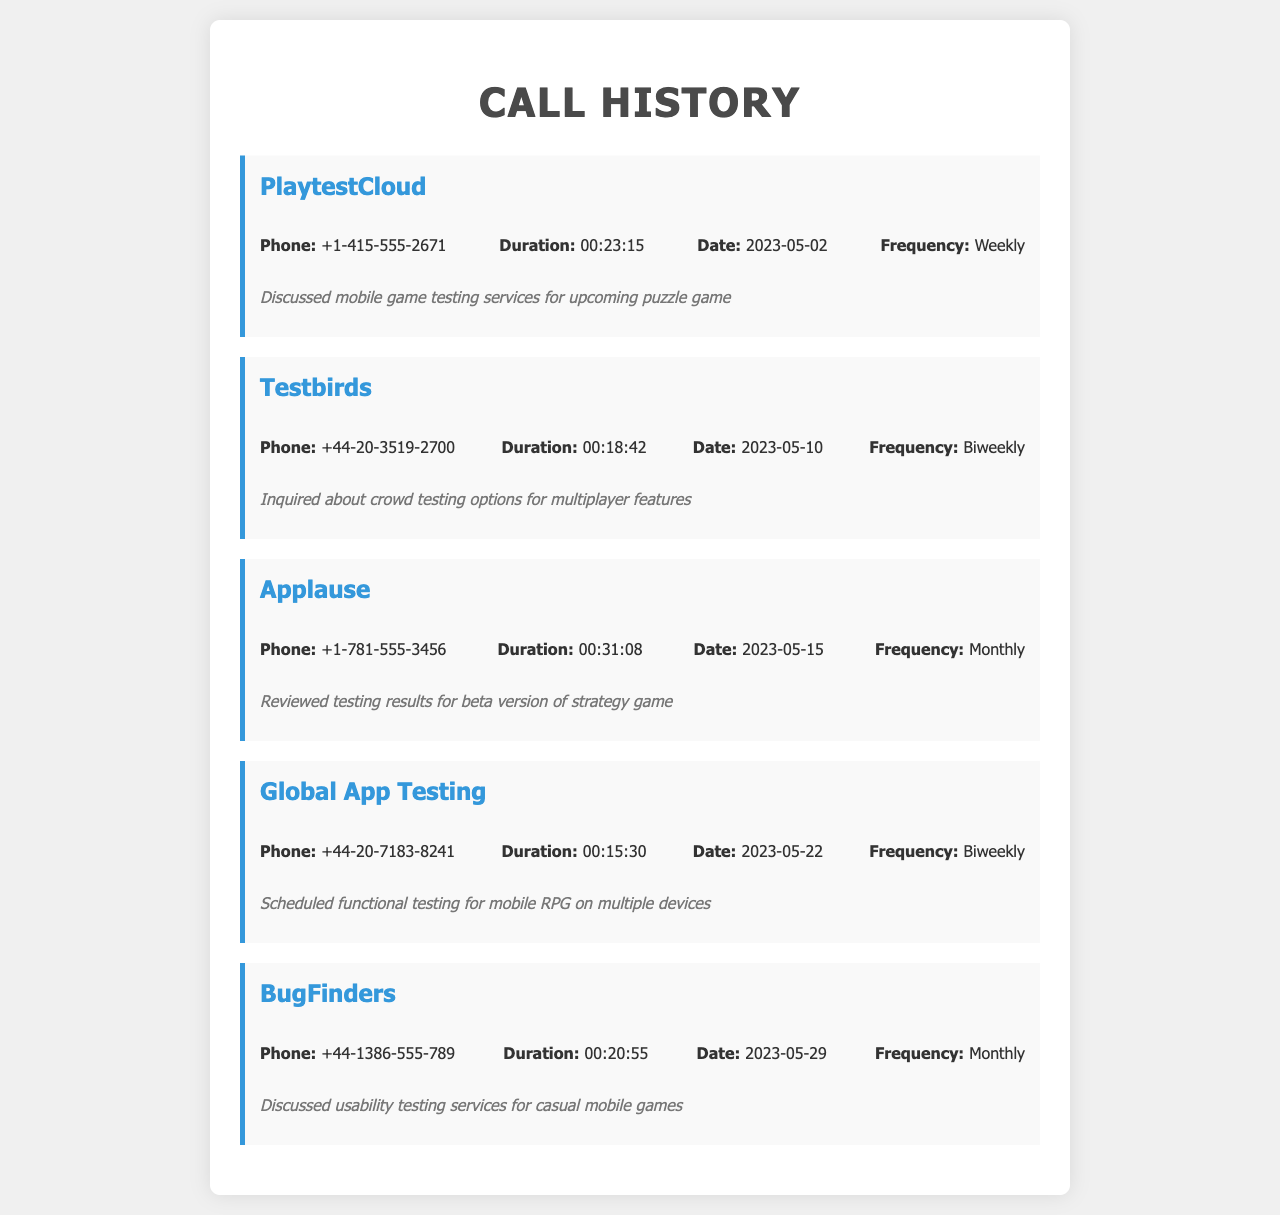What is the phone number for PlaytestCloud? The phone number is provided in the call record for PlaytestCloud, which lists +1-415-555-2671.
Answer: +1-415-555-2671 How long was the call with Testbirds? The duration of the call with Testbirds is listed as 00:18:42.
Answer: 00:18:42 On which date did the call with Applause occur? The date of the call with Applause is mentioned as 2023-05-15.
Answer: 2023-05-15 What type of testing was scheduled with Global App Testing? The notes specify that functional testing for a mobile RPG was scheduled.
Answer: Functional testing for mobile RPG How often do you communicate with BugFinders? The frequency of communication with BugFinders is listed as Monthly.
Answer: Monthly Which service discussed options for multiplayer features? The call record identifies Testbirds as the service discussing options for multiplayer features.
Answer: Testbirds What was a key subject in the call with PlaytestCloud? The notes indicate that the subject discussed was mobile game testing services for an upcoming puzzle game.
Answer: Mobile game testing services for upcoming puzzle game Which company had the longest call duration? The call record shows that Applause had the longest duration at 00:31:08.
Answer: 00:31:08 How many companies are listed in the call history? A count of the entries indicates that there are five companies listed in the call history.
Answer: Five 